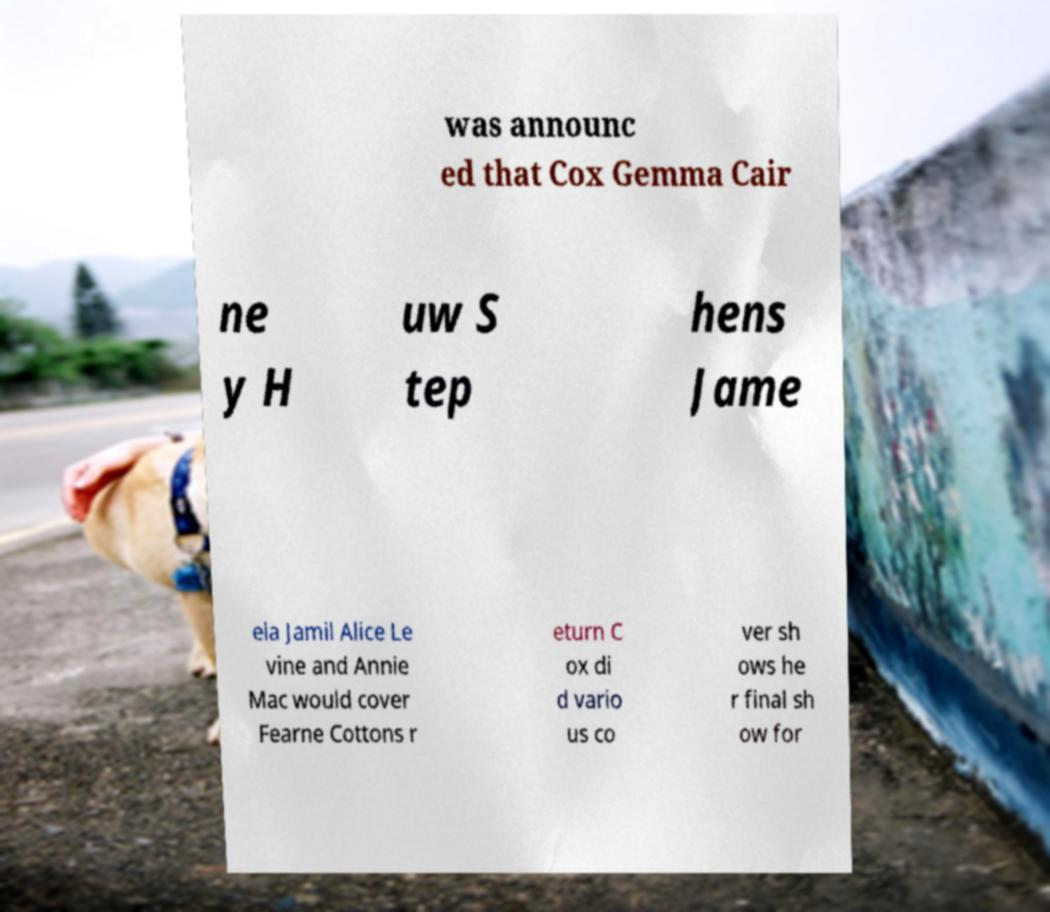For documentation purposes, I need the text within this image transcribed. Could you provide that? was announc ed that Cox Gemma Cair ne y H uw S tep hens Jame ela Jamil Alice Le vine and Annie Mac would cover Fearne Cottons r eturn C ox di d vario us co ver sh ows he r final sh ow for 